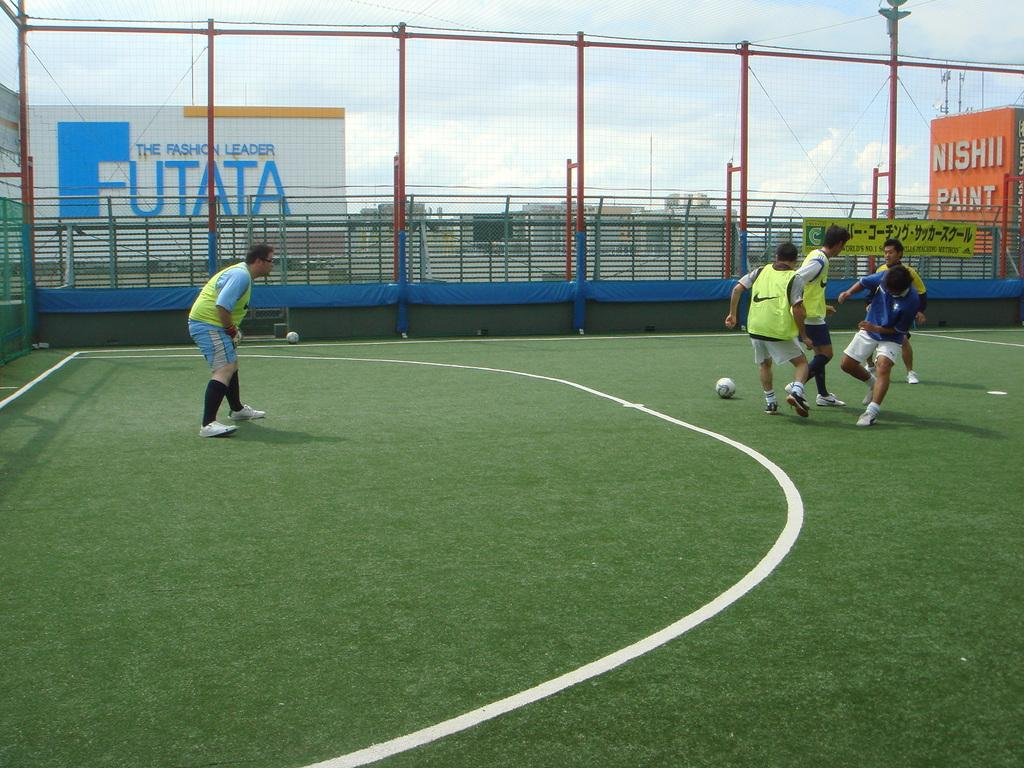<image>
Share a concise interpretation of the image provided. A group of boys are playing soccer next to a Nishi Paint sign. 